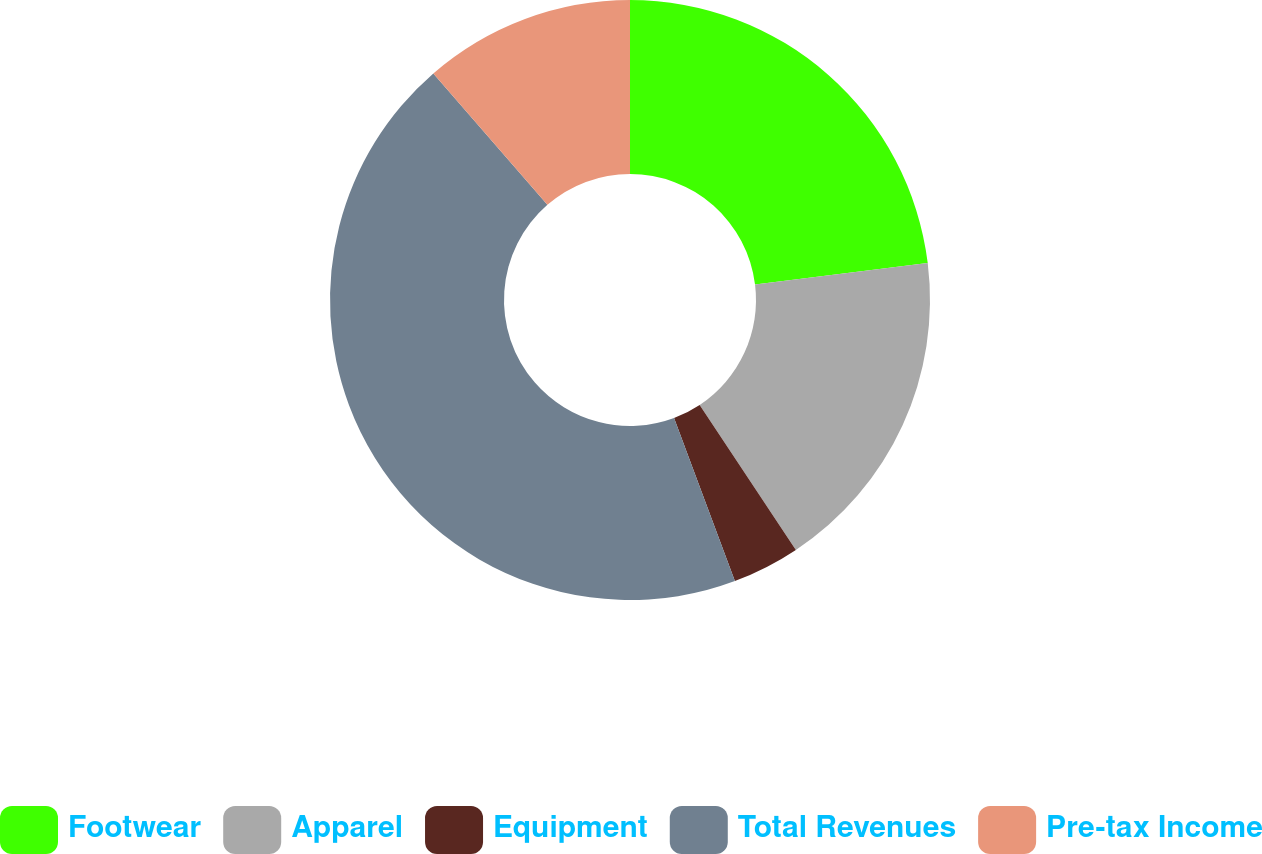Convert chart. <chart><loc_0><loc_0><loc_500><loc_500><pie_chart><fcel>Footwear<fcel>Apparel<fcel>Equipment<fcel>Total Revenues<fcel>Pre-tax Income<nl><fcel>23.04%<fcel>17.64%<fcel>3.64%<fcel>44.31%<fcel>11.38%<nl></chart> 